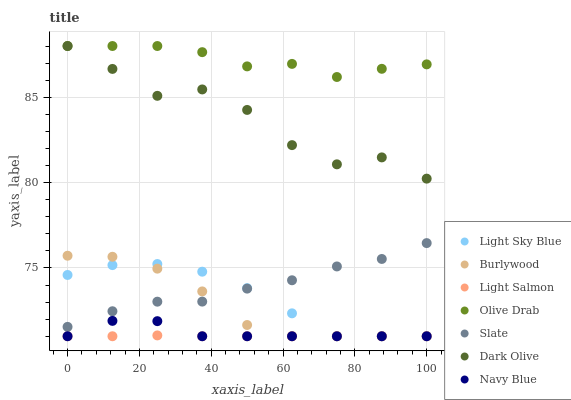Does Light Salmon have the minimum area under the curve?
Answer yes or no. Yes. Does Olive Drab have the maximum area under the curve?
Answer yes or no. Yes. Does Burlywood have the minimum area under the curve?
Answer yes or no. No. Does Burlywood have the maximum area under the curve?
Answer yes or no. No. Is Light Salmon the smoothest?
Answer yes or no. Yes. Is Dark Olive the roughest?
Answer yes or no. Yes. Is Burlywood the smoothest?
Answer yes or no. No. Is Burlywood the roughest?
Answer yes or no. No. Does Light Salmon have the lowest value?
Answer yes or no. Yes. Does Slate have the lowest value?
Answer yes or no. No. Does Olive Drab have the highest value?
Answer yes or no. Yes. Does Burlywood have the highest value?
Answer yes or no. No. Is Slate less than Olive Drab?
Answer yes or no. Yes. Is Olive Drab greater than Navy Blue?
Answer yes or no. Yes. Does Light Sky Blue intersect Navy Blue?
Answer yes or no. Yes. Is Light Sky Blue less than Navy Blue?
Answer yes or no. No. Is Light Sky Blue greater than Navy Blue?
Answer yes or no. No. Does Slate intersect Olive Drab?
Answer yes or no. No. 